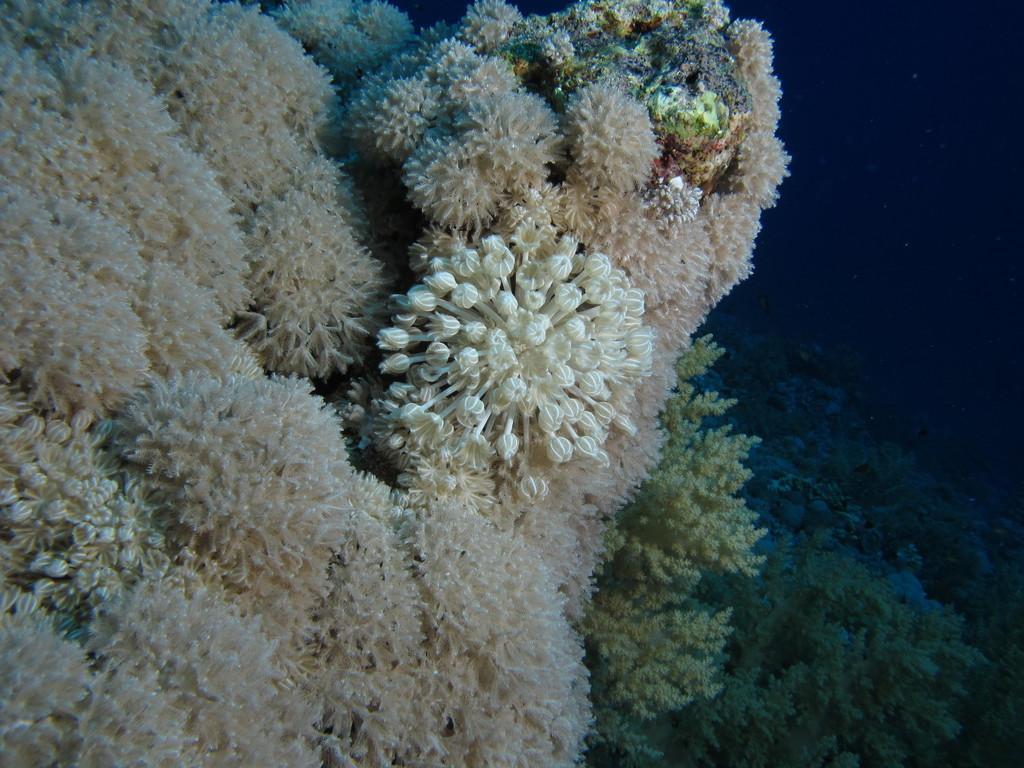Can you describe this image briefly? In this image there are underwater plants. 